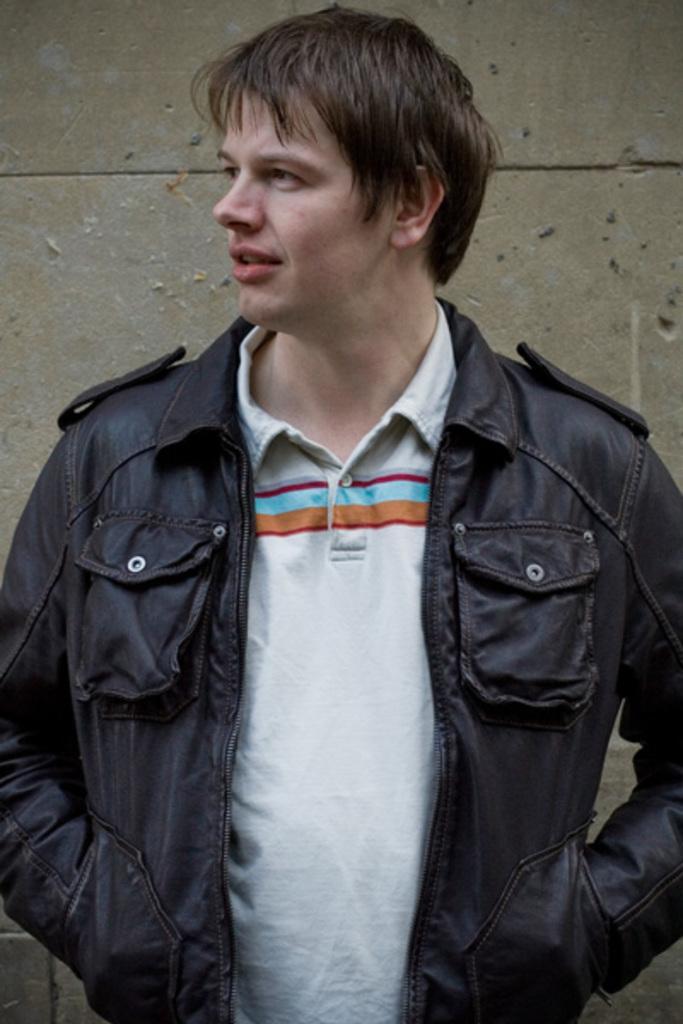Could you give a brief overview of what you see in this image? In the center of the image we can see a man is standing and wearing jacket. In the background of the image we can see the wall. 